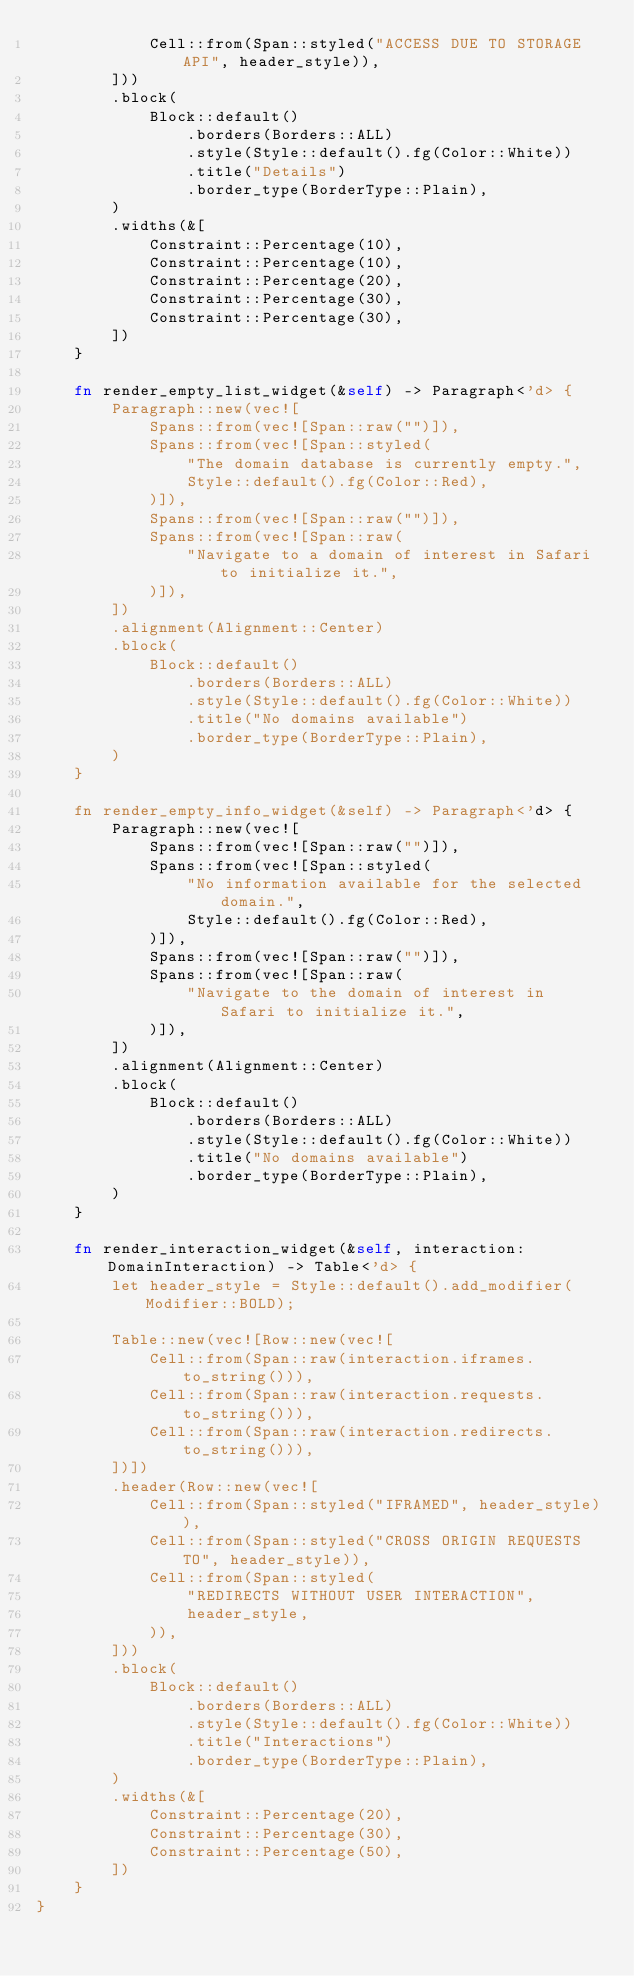Convert code to text. <code><loc_0><loc_0><loc_500><loc_500><_Rust_>            Cell::from(Span::styled("ACCESS DUE TO STORAGE API", header_style)),
        ]))
        .block(
            Block::default()
                .borders(Borders::ALL)
                .style(Style::default().fg(Color::White))
                .title("Details")
                .border_type(BorderType::Plain),
        )
        .widths(&[
            Constraint::Percentage(10),
            Constraint::Percentage(10),
            Constraint::Percentage(20),
            Constraint::Percentage(30),
            Constraint::Percentage(30),
        ])
    }

    fn render_empty_list_widget(&self) -> Paragraph<'d> {
        Paragraph::new(vec![
            Spans::from(vec![Span::raw("")]),
            Spans::from(vec![Span::styled(
                "The domain database is currently empty.",
                Style::default().fg(Color::Red),
            )]),
            Spans::from(vec![Span::raw("")]),
            Spans::from(vec![Span::raw(
                "Navigate to a domain of interest in Safari to initialize it.",
            )]),
        ])
        .alignment(Alignment::Center)
        .block(
            Block::default()
                .borders(Borders::ALL)
                .style(Style::default().fg(Color::White))
                .title("No domains available")
                .border_type(BorderType::Plain),
        )
    }

    fn render_empty_info_widget(&self) -> Paragraph<'d> {
        Paragraph::new(vec![
            Spans::from(vec![Span::raw("")]),
            Spans::from(vec![Span::styled(
                "No information available for the selected domain.",
                Style::default().fg(Color::Red),
            )]),
            Spans::from(vec![Span::raw("")]),
            Spans::from(vec![Span::raw(
                "Navigate to the domain of interest in Safari to initialize it.",
            )]),
        ])
        .alignment(Alignment::Center)
        .block(
            Block::default()
                .borders(Borders::ALL)
                .style(Style::default().fg(Color::White))
                .title("No domains available")
                .border_type(BorderType::Plain),
        )
    }

    fn render_interaction_widget(&self, interaction: DomainInteraction) -> Table<'d> {
        let header_style = Style::default().add_modifier(Modifier::BOLD);

        Table::new(vec![Row::new(vec![
            Cell::from(Span::raw(interaction.iframes.to_string())),
            Cell::from(Span::raw(interaction.requests.to_string())),
            Cell::from(Span::raw(interaction.redirects.to_string())),
        ])])
        .header(Row::new(vec![
            Cell::from(Span::styled("IFRAMED", header_style)),
            Cell::from(Span::styled("CROSS ORIGIN REQUESTS TO", header_style)),
            Cell::from(Span::styled(
                "REDIRECTS WITHOUT USER INTERACTION",
                header_style,
            )),
        ]))
        .block(
            Block::default()
                .borders(Borders::ALL)
                .style(Style::default().fg(Color::White))
                .title("Interactions")
                .border_type(BorderType::Plain),
        )
        .widths(&[
            Constraint::Percentage(20),
            Constraint::Percentage(30),
            Constraint::Percentage(50),
        ])
    }
}
</code> 